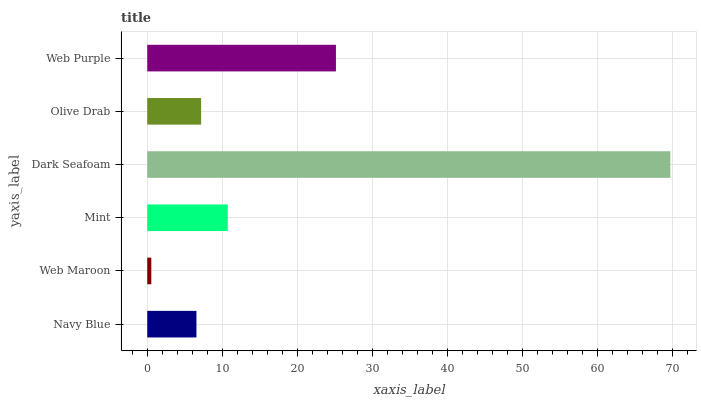Is Web Maroon the minimum?
Answer yes or no. Yes. Is Dark Seafoam the maximum?
Answer yes or no. Yes. Is Mint the minimum?
Answer yes or no. No. Is Mint the maximum?
Answer yes or no. No. Is Mint greater than Web Maroon?
Answer yes or no. Yes. Is Web Maroon less than Mint?
Answer yes or no. Yes. Is Web Maroon greater than Mint?
Answer yes or no. No. Is Mint less than Web Maroon?
Answer yes or no. No. Is Mint the high median?
Answer yes or no. Yes. Is Olive Drab the low median?
Answer yes or no. Yes. Is Dark Seafoam the high median?
Answer yes or no. No. Is Dark Seafoam the low median?
Answer yes or no. No. 